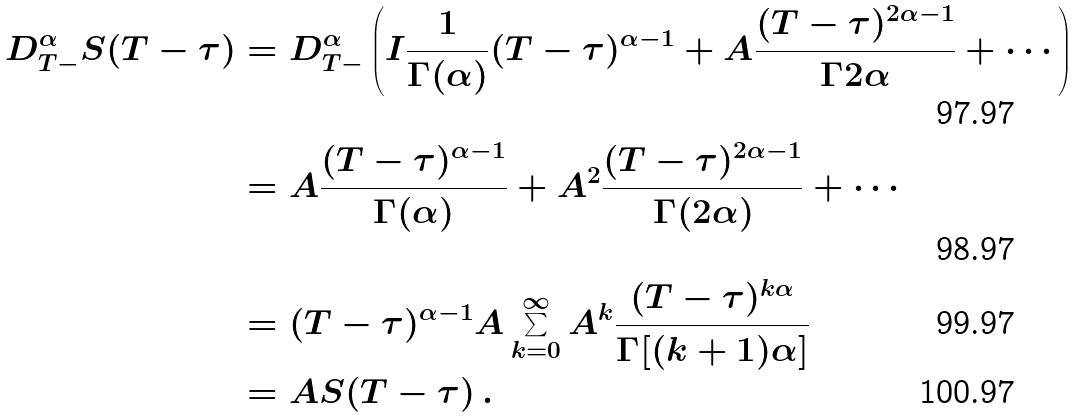<formula> <loc_0><loc_0><loc_500><loc_500>D ^ { \alpha } _ { T - } S ( T - \tau ) & = D ^ { \alpha } _ { T - } \left ( I \frac { 1 } { \Gamma ( \alpha ) } ( T - \tau ) ^ { \alpha - 1 } + A \frac { ( T - \tau ) ^ { 2 \alpha - 1 } } { \Gamma { 2 \alpha } } + \cdots \right ) \\ & = A \frac { ( T - \tau ) ^ { \alpha - 1 } } { \Gamma ( \alpha ) } + A ^ { 2 } \frac { ( T - \tau ) ^ { 2 \alpha - 1 } } { \Gamma ( 2 \alpha ) } + \cdots \\ & = ( T - \tau ) ^ { \alpha - 1 } A \sum _ { k = 0 } ^ { \infty } A ^ { k } \frac { ( T - \tau ) ^ { k \alpha } } { \Gamma [ ( k + 1 ) \alpha ] } \\ & = A S ( T - \tau ) \, .</formula> 